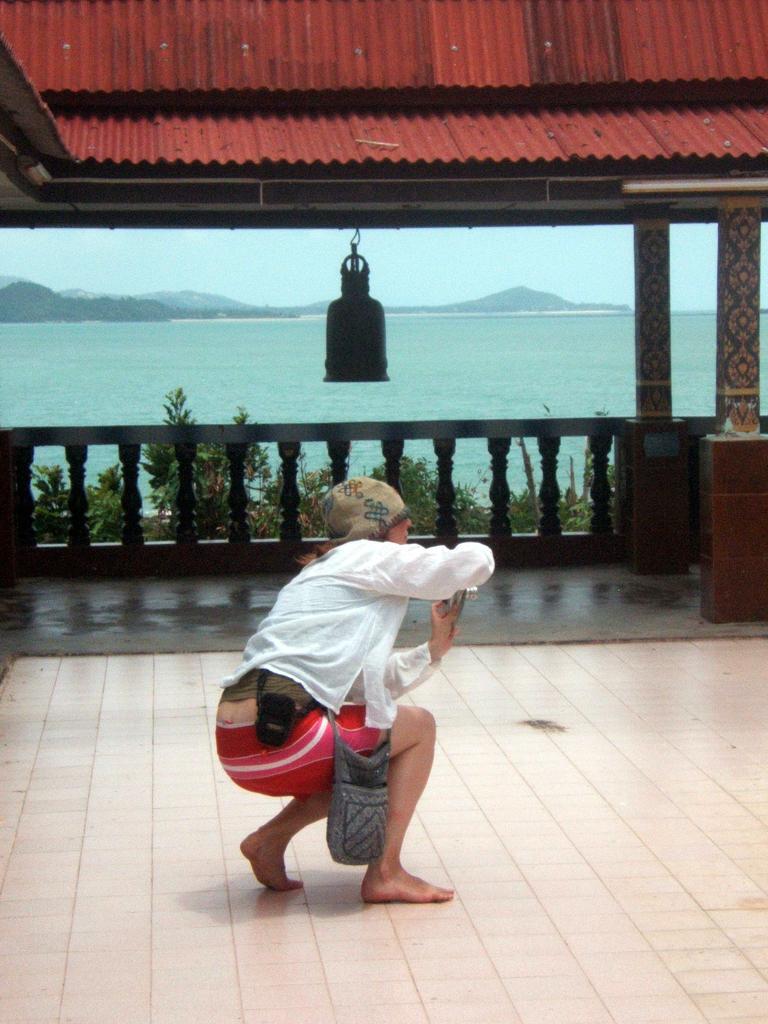In one or two sentences, can you explain what this image depicts? Here I can see a person sitting facing towards the right side and holding a camera in the hands. In the background, I can see two pillars, railing and few plants and an object is hanging to the top. In the background, I can see a river, hill and sky. 